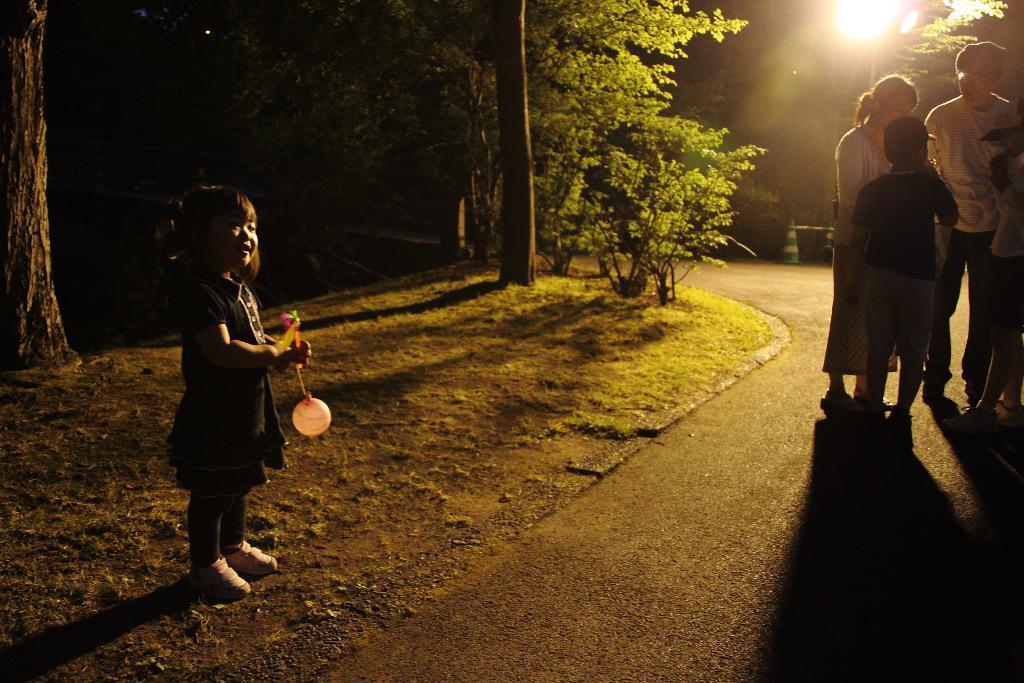In one or two sentences, can you explain what this image depicts? In this picture I can see there is a girl standing at left, she is holding a balloon and wearing a dress and shoes, she is looking at left side. There is a man and a woman and two kids standing on top right on the road. There are plants, trees at left and there are few more trees and the sun is visible in the sky. 